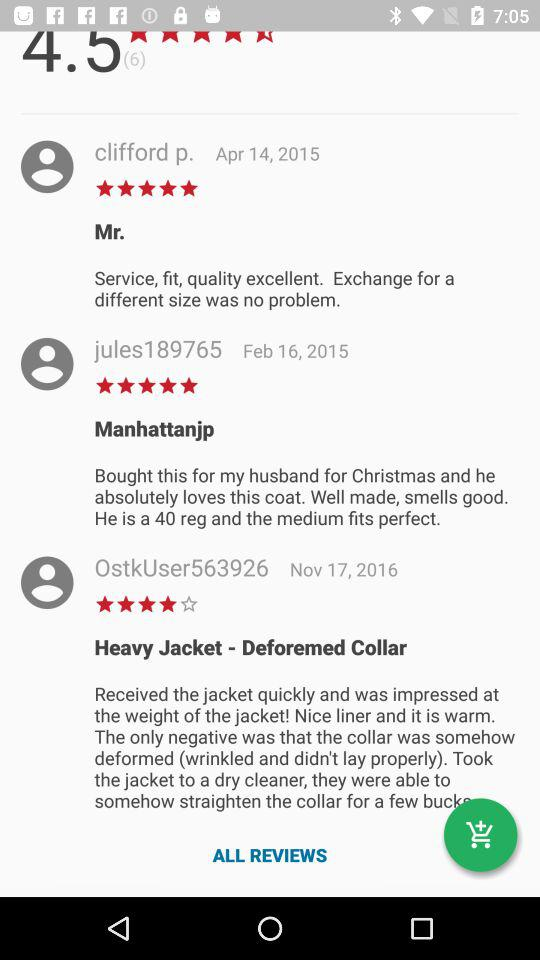What is the star rating given by "jules189765"? The given rating is 5 stars. 